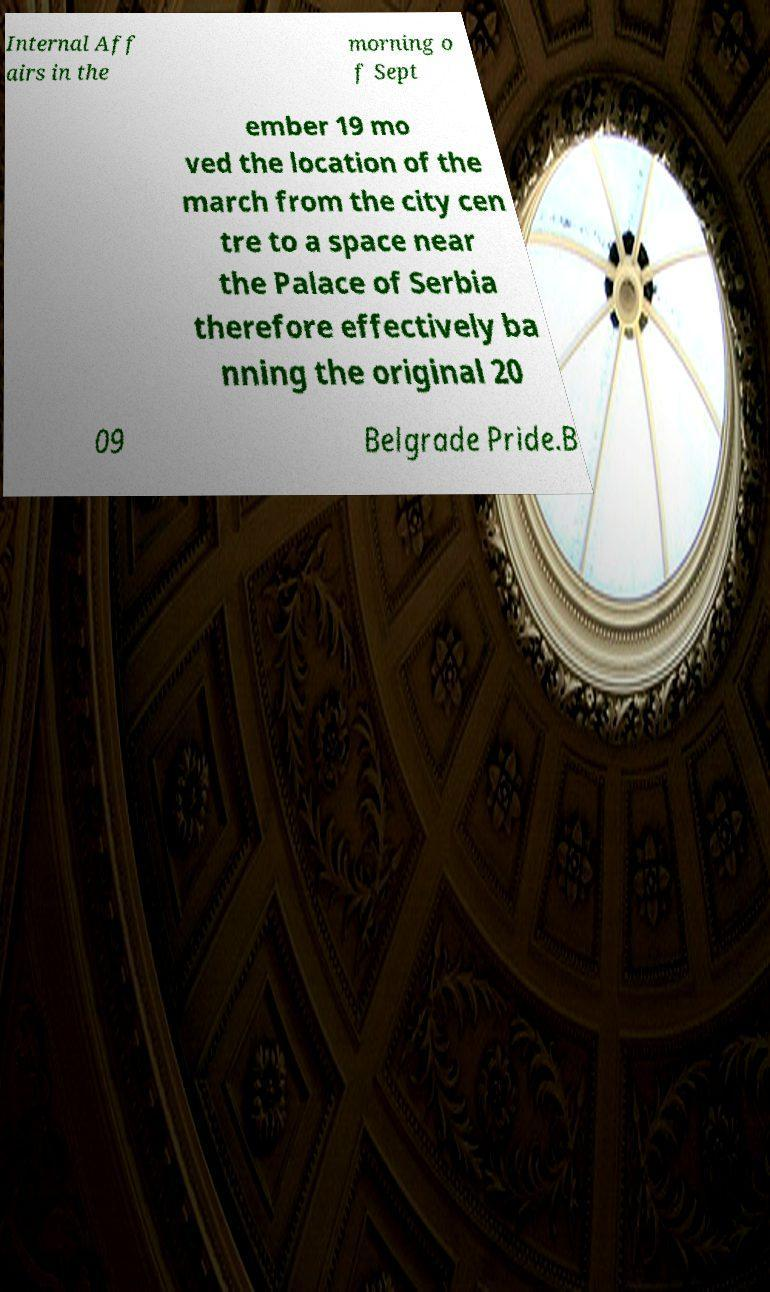For documentation purposes, I need the text within this image transcribed. Could you provide that? Internal Aff airs in the morning o f Sept ember 19 mo ved the location of the march from the city cen tre to a space near the Palace of Serbia therefore effectively ba nning the original 20 09 Belgrade Pride.B 